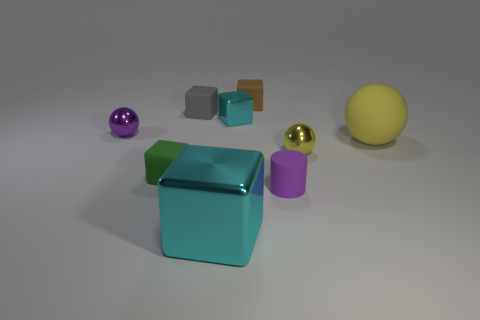Is there a yellow object that has the same size as the green rubber object?
Your response must be concise. Yes. Is the shape of the tiny cyan metal thing the same as the tiny purple thing in front of the tiny green object?
Your response must be concise. No. How many balls are either green objects or gray things?
Provide a short and direct response. 0. What color is the rubber cylinder?
Provide a short and direct response. Purple. Are there more small brown things than purple blocks?
Your answer should be compact. Yes. How many things are either small balls that are in front of the big sphere or tiny matte things?
Give a very brief answer. 5. Is the material of the gray block the same as the large yellow thing?
Offer a terse response. Yes. There is another yellow object that is the same shape as the yellow metal thing; what is its size?
Provide a short and direct response. Large. Do the small rubber thing that is behind the gray thing and the cyan shiny thing that is on the left side of the tiny cyan block have the same shape?
Offer a very short reply. Yes. There is a green rubber thing; is its size the same as the shiny cube in front of the small purple ball?
Your response must be concise. No. 